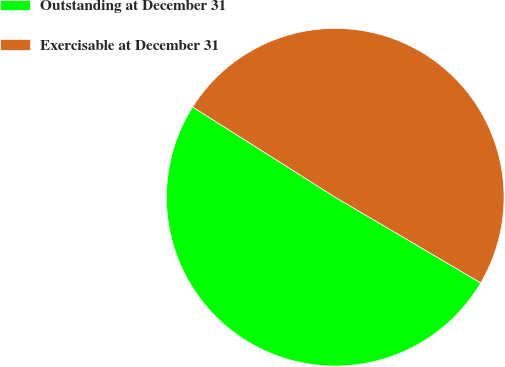Convert chart to OTSL. <chart><loc_0><loc_0><loc_500><loc_500><pie_chart><fcel>Outstanding at December 31<fcel>Exercisable at December 31<nl><fcel>50.52%<fcel>49.48%<nl></chart> 